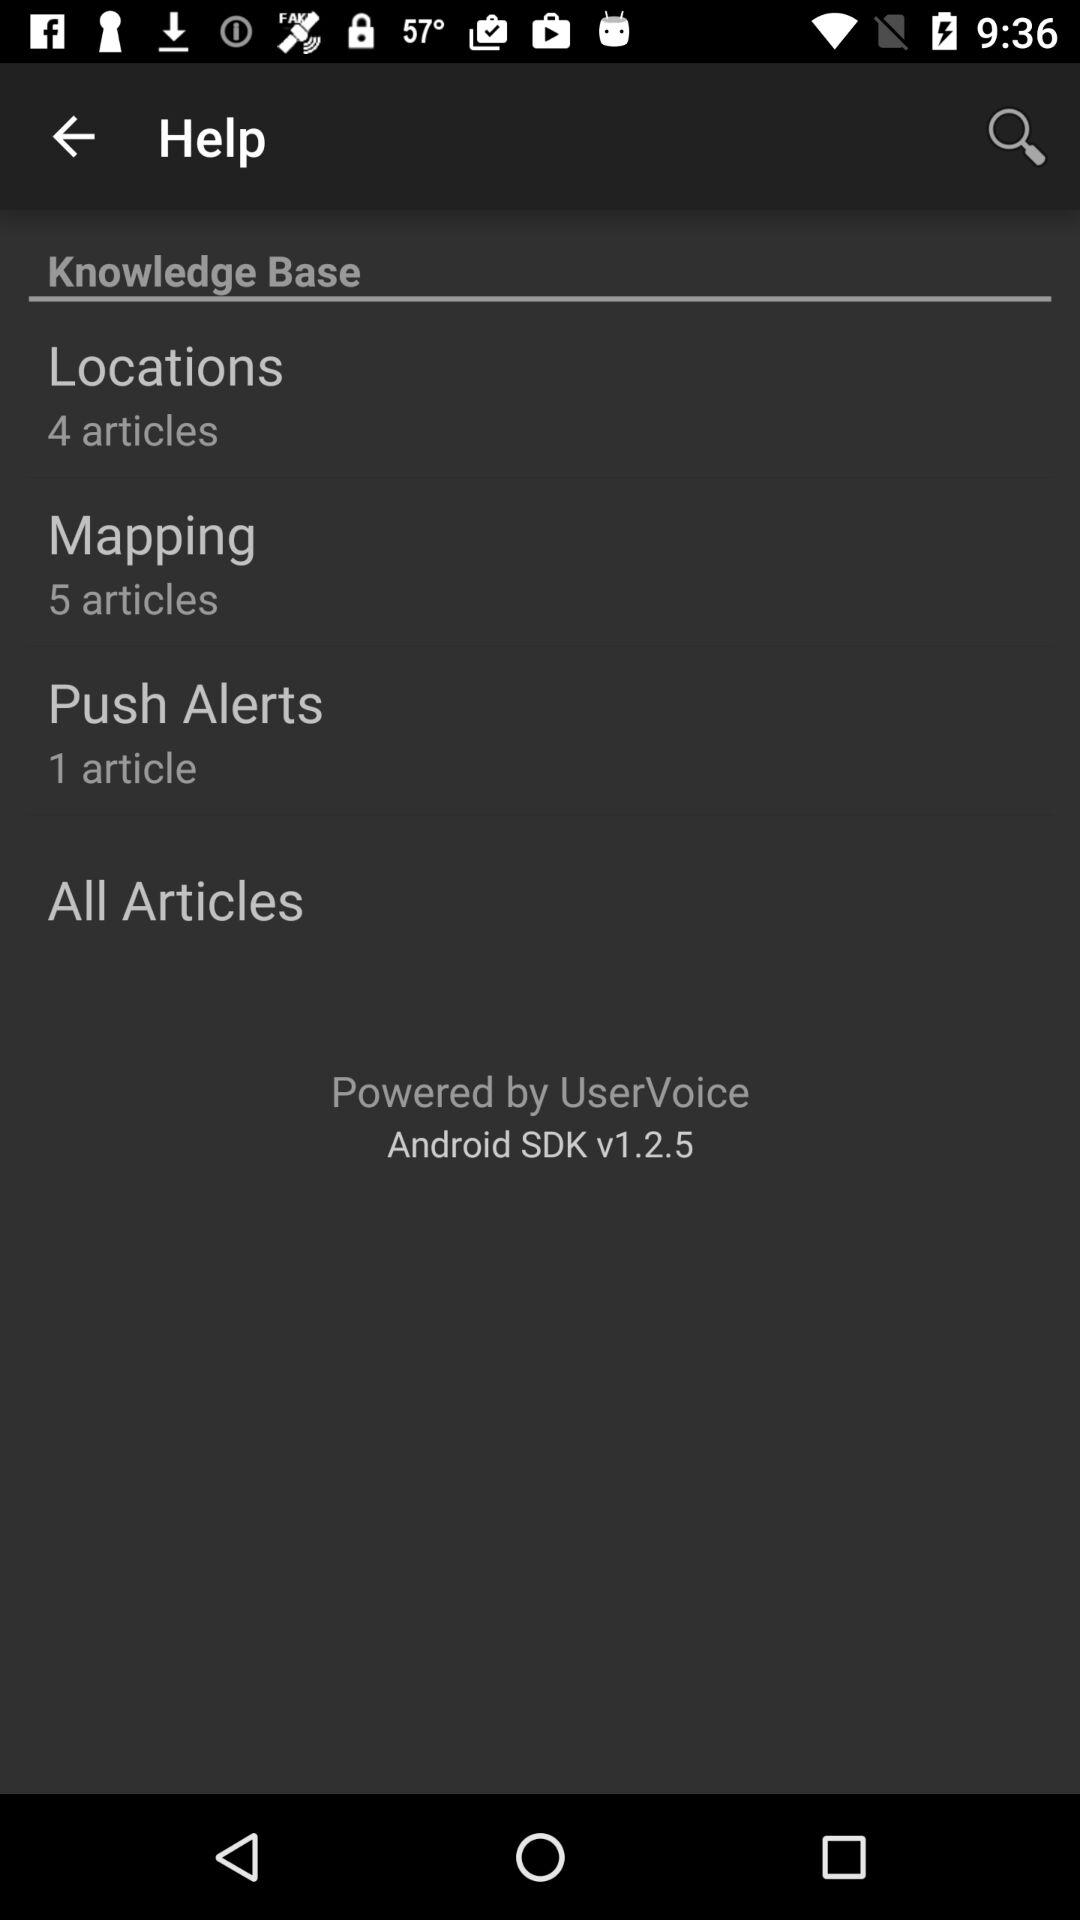How many articles are present in the "Push Alerts"? There is 1 article present in the "Push Alerts". 